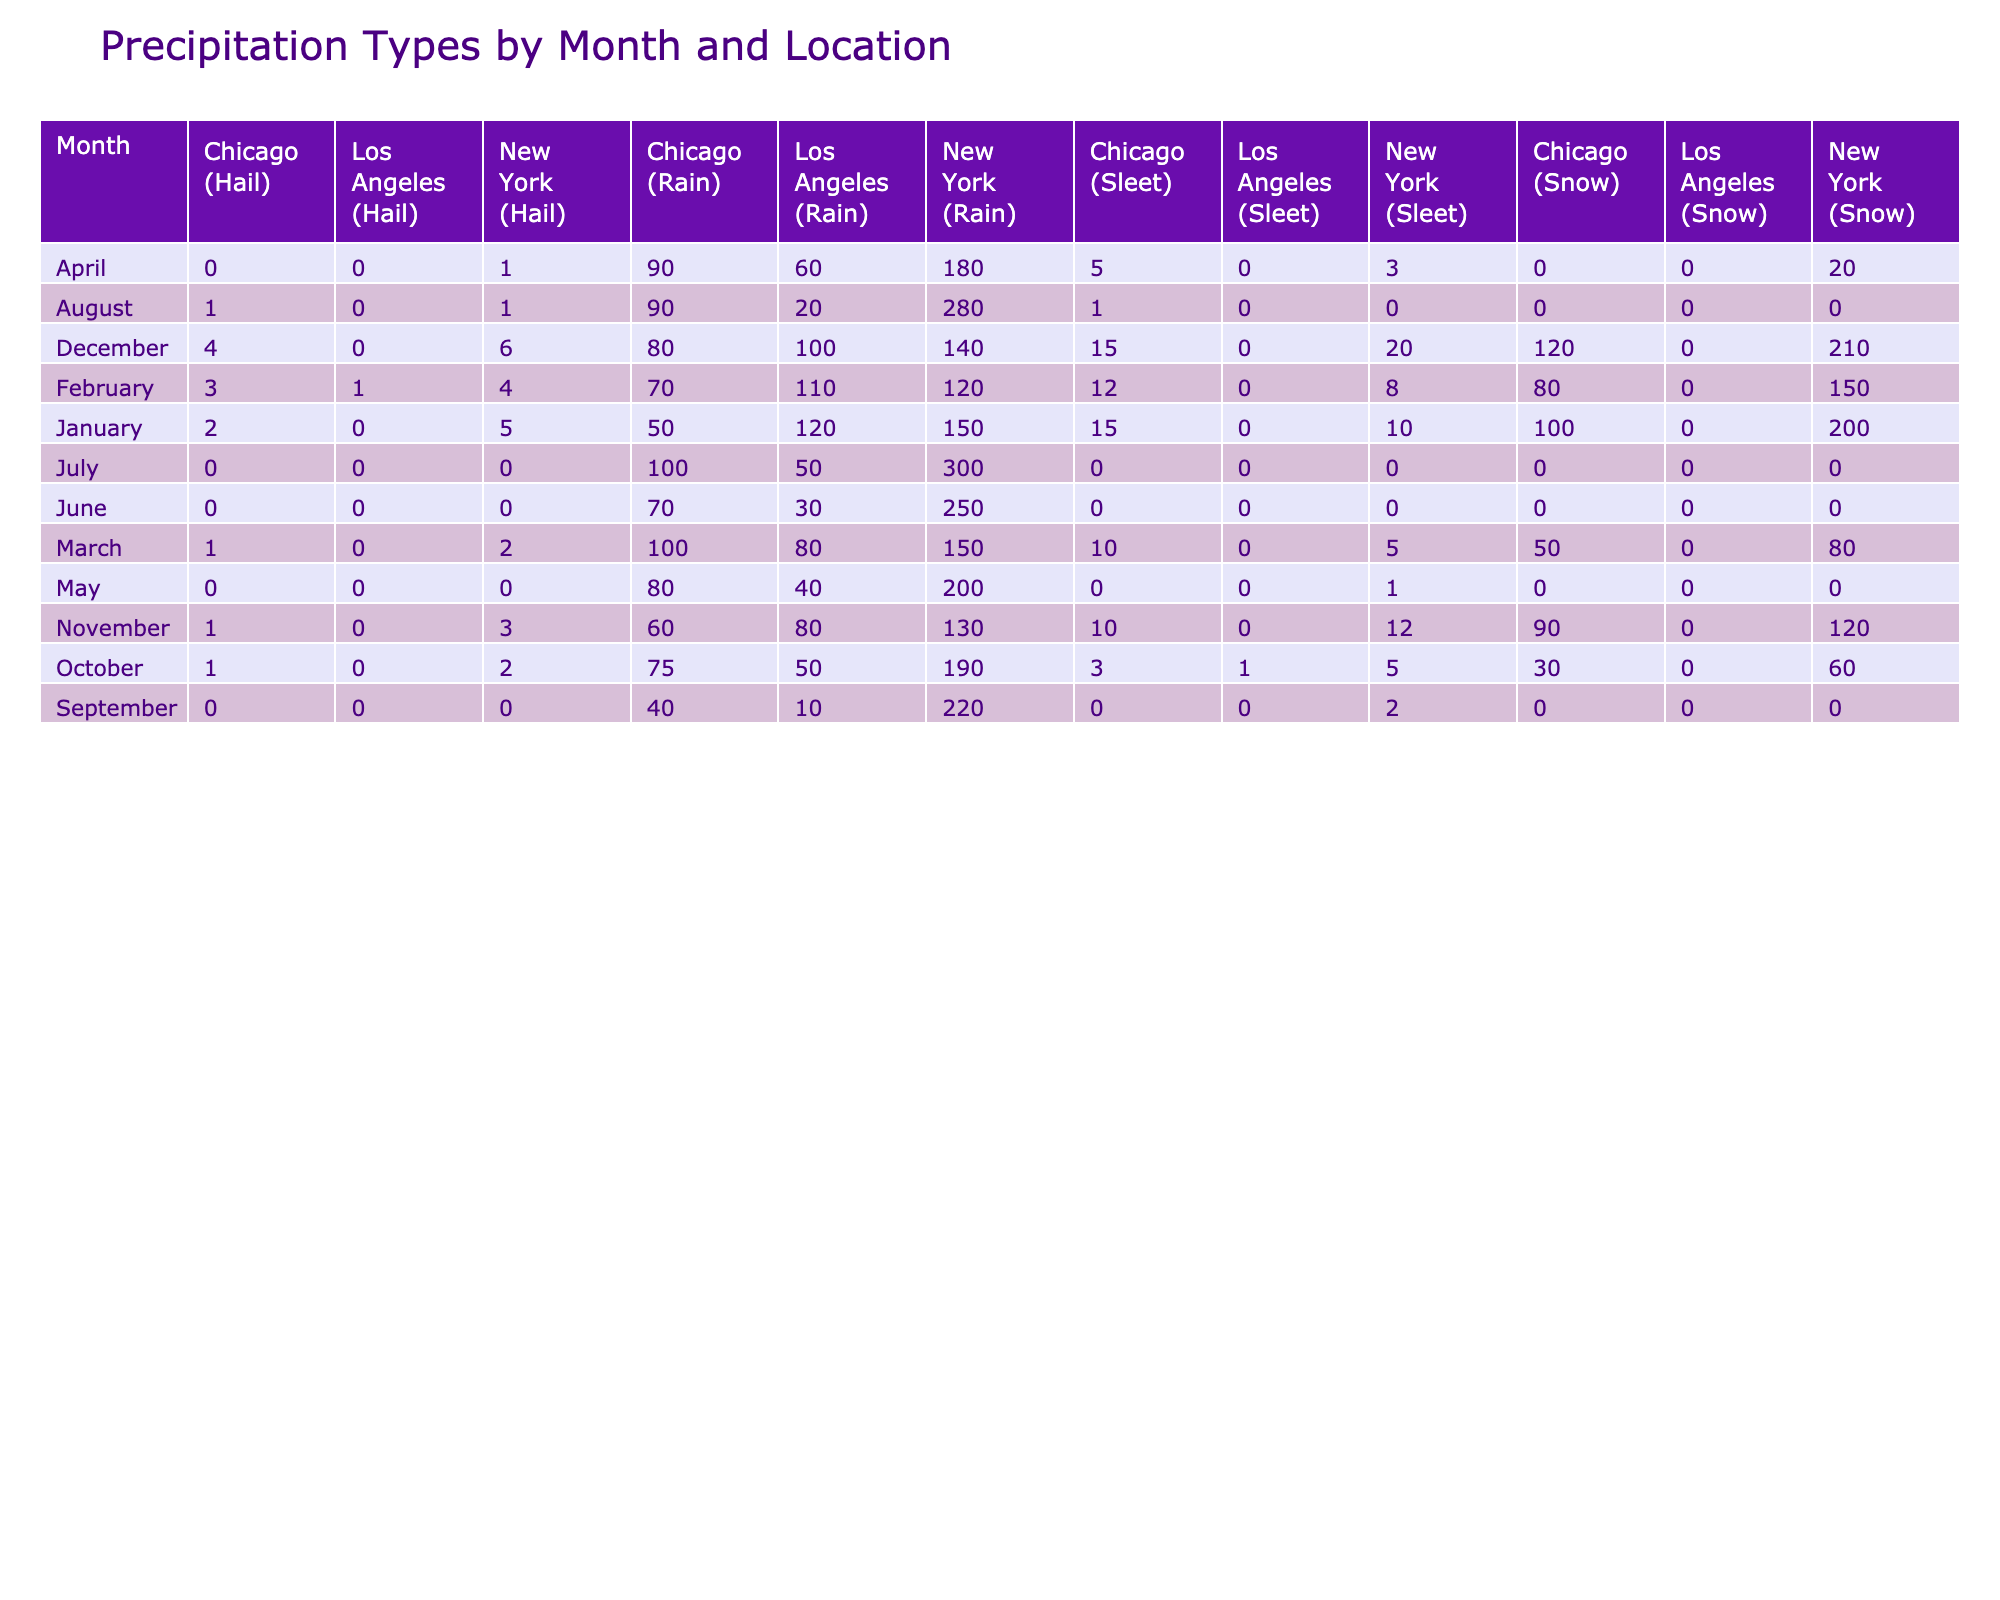What is the total amount of Snow observed in January across all locations? In January, the snow amounts for each location are: New York (200), Los Angeles (0), and Chicago (100). Summing these values gives 200 + 0 + 100 = 300.
Answer: 300 How much Rain was recorded in Los Angeles in April? In April, the table shows that the amount of Rain in Los Angeles is 60.
Answer: 60 Is there any Sleet recorded in April in Chicago? In April, the Sleet amount for Chicago is 5. Therefore, it is true that there is Sleet recorded.
Answer: Yes What is the average amount of Hail recorded in New York over the months? The Hail amounts for New York are: January (5), February (4), March (2), April (1), May (0), June (0), July (0), August (1), September (0), October (2), November (3), and December (6). Summing these gives 5 + 4 + 2 + 1 + 0 + 0 + 0 + 1 + 0 + 2 + 3 + 6 = 24. There are 12 data points, so the average is 24 / 12 = 2.
Answer: 2 Which location observed the highest total amount of Rain in December? In December, the Rain amounts are: New York (140), Los Angeles (100), and Chicago (80). New York has the highest amount with 140.
Answer: New York 